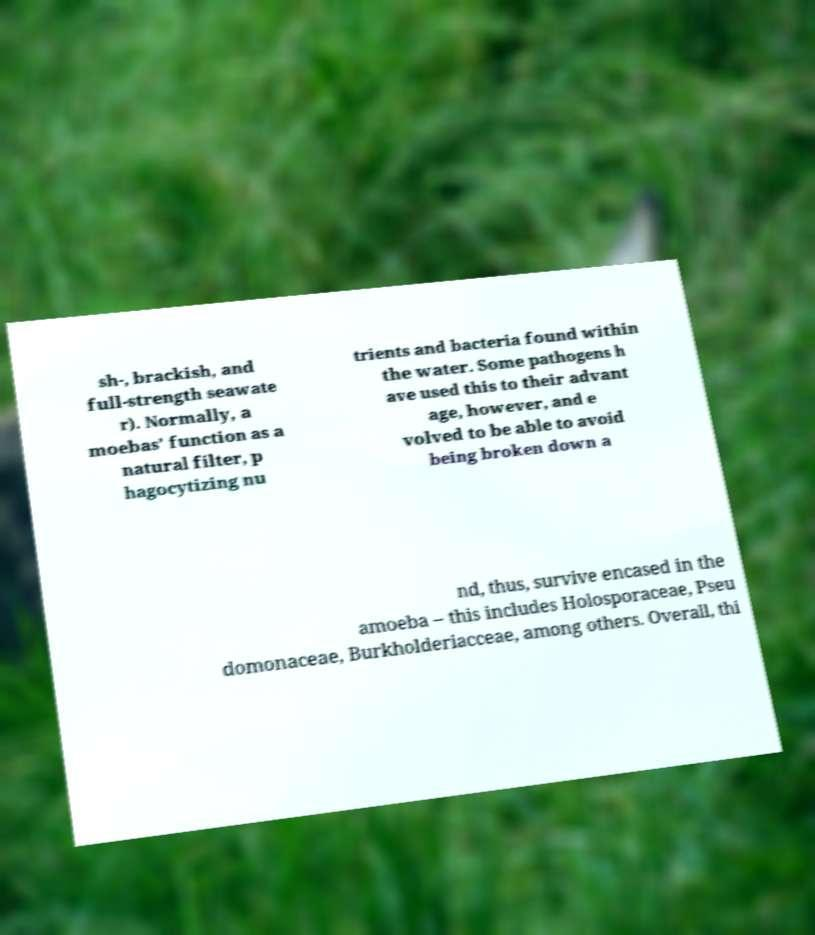What messages or text are displayed in this image? I need them in a readable, typed format. sh-, brackish, and full-strength seawate r). Normally, a moebas’ function as a natural filter, p hagocytizing nu trients and bacteria found within the water. Some pathogens h ave used this to their advant age, however, and e volved to be able to avoid being broken down a nd, thus, survive encased in the amoeba – this includes Holosporaceae, Pseu domonaceae, Burkholderiacceae, among others. Overall, thi 